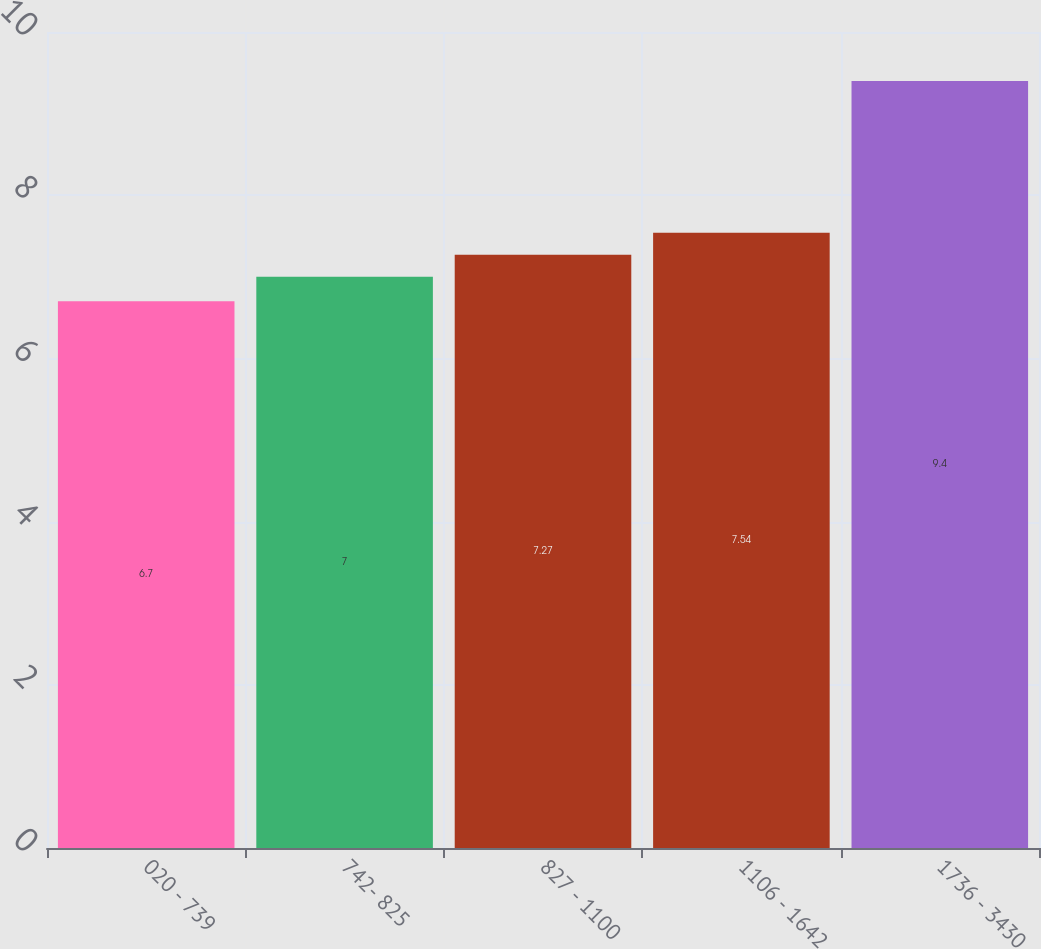<chart> <loc_0><loc_0><loc_500><loc_500><bar_chart><fcel>020 - 739<fcel>742- 825<fcel>827 - 1100<fcel>1106 - 1642<fcel>1736 - 3430<nl><fcel>6.7<fcel>7<fcel>7.27<fcel>7.54<fcel>9.4<nl></chart> 